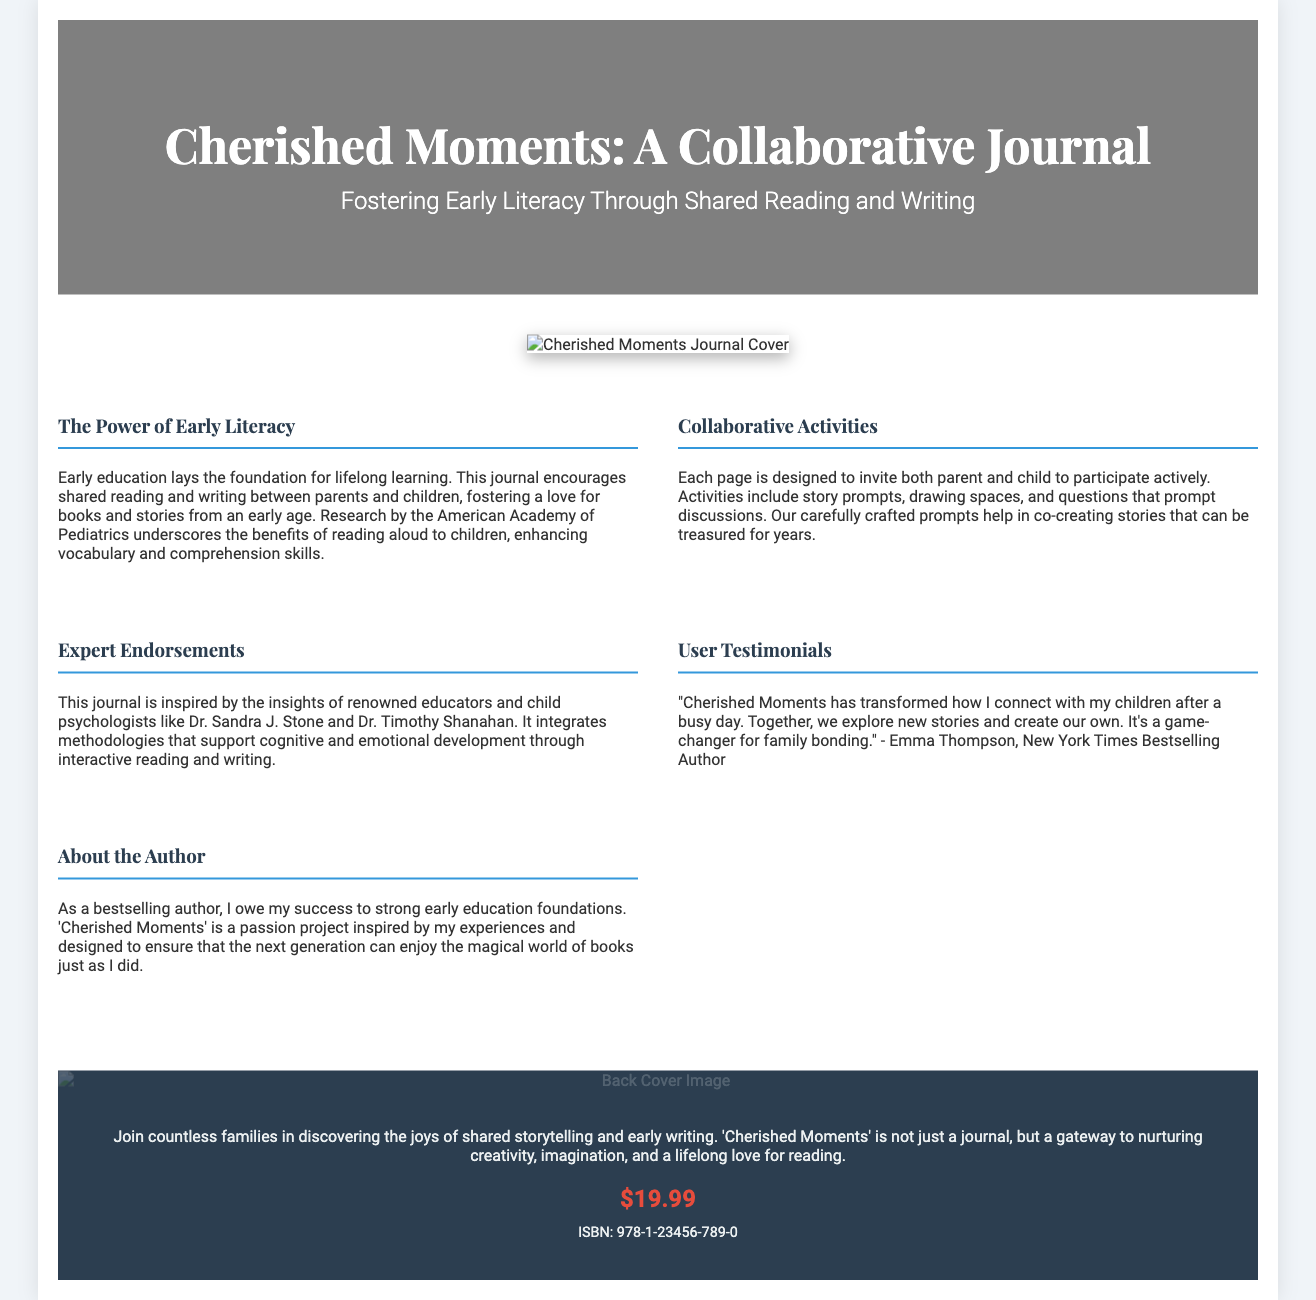What is the title of the journal? The title of the journal is explicitly mentioned in the header of the document.
Answer: Cherished Moments: A Collaborative Journal What is the price of the journal? The price is stated prominently in the back cover section of the document.
Answer: $19.99 Who is the inspiration behind the journal? The document mentions renowned educators and child psychologists who inspired the journal's design.
Answer: Dr. Sandra J. Stone and Dr. Timothy Shanahan What is the main focus of the journal? The focus is highlighted in the subtitle, indicating the purpose of the journal.
Answer: Fostering Early Literacy Through Shared Reading and Writing What type of activities does the journal include? The section on collaborative activities details the type of engagement the journal encourages.
Answer: Story prompts, drawing spaces, and questions Who provided a testimonial about the journal? A personal endorsement is given by a notable figure mentioned in the document.
Answer: Emma Thompson What does the back cover content encourage families to discover? The back cover emphasizes the key experience that the journal aims to provide.
Answer: The joys of shared storytelling and early writing What foundational element does the author attribute their success to? The author refers to an essential aspect of learning that influenced their achievements.
Answer: Strong early education foundations 